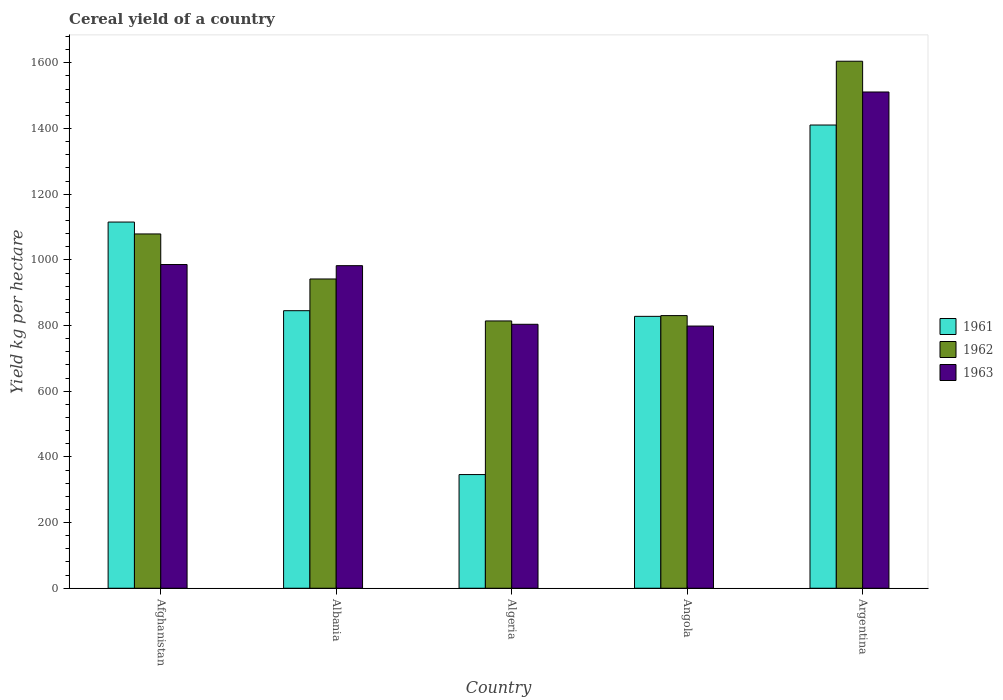Are the number of bars per tick equal to the number of legend labels?
Offer a terse response. Yes. Are the number of bars on each tick of the X-axis equal?
Offer a very short reply. Yes. How many bars are there on the 3rd tick from the right?
Make the answer very short. 3. What is the label of the 3rd group of bars from the left?
Ensure brevity in your answer.  Algeria. In how many cases, is the number of bars for a given country not equal to the number of legend labels?
Offer a terse response. 0. What is the total cereal yield in 1961 in Algeria?
Provide a short and direct response. 346.15. Across all countries, what is the maximum total cereal yield in 1963?
Make the answer very short. 1511.24. Across all countries, what is the minimum total cereal yield in 1962?
Your response must be concise. 814. In which country was the total cereal yield in 1963 maximum?
Your response must be concise. Argentina. In which country was the total cereal yield in 1963 minimum?
Give a very brief answer. Angola. What is the total total cereal yield in 1963 in the graph?
Offer a terse response. 5081.71. What is the difference between the total cereal yield in 1962 in Angola and that in Argentina?
Your response must be concise. -774.65. What is the difference between the total cereal yield in 1963 in Algeria and the total cereal yield in 1962 in Angola?
Keep it short and to the point. -26.44. What is the average total cereal yield in 1961 per country?
Provide a succinct answer. 909.03. What is the difference between the total cereal yield of/in 1963 and total cereal yield of/in 1962 in Argentina?
Your answer should be very brief. -93.68. In how many countries, is the total cereal yield in 1961 greater than 640 kg per hectare?
Offer a terse response. 4. What is the ratio of the total cereal yield in 1961 in Albania to that in Angola?
Provide a short and direct response. 1.02. Is the total cereal yield in 1961 in Afghanistan less than that in Argentina?
Your response must be concise. Yes. Is the difference between the total cereal yield in 1963 in Albania and Algeria greater than the difference between the total cereal yield in 1962 in Albania and Algeria?
Keep it short and to the point. Yes. What is the difference between the highest and the second highest total cereal yield in 1963?
Ensure brevity in your answer.  3.51. What is the difference between the highest and the lowest total cereal yield in 1963?
Your answer should be compact. 712.79. What does the 1st bar from the left in Algeria represents?
Make the answer very short. 1961. Is it the case that in every country, the sum of the total cereal yield in 1963 and total cereal yield in 1962 is greater than the total cereal yield in 1961?
Provide a succinct answer. Yes. Are the values on the major ticks of Y-axis written in scientific E-notation?
Your answer should be compact. No. Does the graph contain grids?
Make the answer very short. No. How many legend labels are there?
Your answer should be compact. 3. How are the legend labels stacked?
Offer a terse response. Vertical. What is the title of the graph?
Offer a very short reply. Cereal yield of a country. What is the label or title of the X-axis?
Offer a very short reply. Country. What is the label or title of the Y-axis?
Your response must be concise. Yield kg per hectare. What is the Yield kg per hectare of 1961 in Afghanistan?
Your answer should be very brief. 1115.13. What is the Yield kg per hectare in 1962 in Afghanistan?
Make the answer very short. 1078.97. What is the Yield kg per hectare in 1963 in Afghanistan?
Your response must be concise. 985.85. What is the Yield kg per hectare in 1961 in Albania?
Your response must be concise. 845.21. What is the Yield kg per hectare of 1962 in Albania?
Give a very brief answer. 941.8. What is the Yield kg per hectare in 1963 in Albania?
Keep it short and to the point. 982.34. What is the Yield kg per hectare of 1961 in Algeria?
Your response must be concise. 346.15. What is the Yield kg per hectare of 1962 in Algeria?
Offer a very short reply. 814. What is the Yield kg per hectare of 1963 in Algeria?
Ensure brevity in your answer.  803.83. What is the Yield kg per hectare of 1961 in Angola?
Your answer should be compact. 828.01. What is the Yield kg per hectare of 1962 in Angola?
Make the answer very short. 830.27. What is the Yield kg per hectare of 1963 in Angola?
Provide a succinct answer. 798.45. What is the Yield kg per hectare of 1961 in Argentina?
Offer a terse response. 1410.65. What is the Yield kg per hectare in 1962 in Argentina?
Provide a succinct answer. 1604.92. What is the Yield kg per hectare of 1963 in Argentina?
Your response must be concise. 1511.24. Across all countries, what is the maximum Yield kg per hectare of 1961?
Ensure brevity in your answer.  1410.65. Across all countries, what is the maximum Yield kg per hectare in 1962?
Offer a very short reply. 1604.92. Across all countries, what is the maximum Yield kg per hectare in 1963?
Your answer should be compact. 1511.24. Across all countries, what is the minimum Yield kg per hectare in 1961?
Provide a succinct answer. 346.15. Across all countries, what is the minimum Yield kg per hectare of 1962?
Ensure brevity in your answer.  814. Across all countries, what is the minimum Yield kg per hectare of 1963?
Provide a short and direct response. 798.45. What is the total Yield kg per hectare in 1961 in the graph?
Your response must be concise. 4545.15. What is the total Yield kg per hectare of 1962 in the graph?
Provide a succinct answer. 5269.97. What is the total Yield kg per hectare in 1963 in the graph?
Provide a succinct answer. 5081.71. What is the difference between the Yield kg per hectare in 1961 in Afghanistan and that in Albania?
Offer a terse response. 269.93. What is the difference between the Yield kg per hectare in 1962 in Afghanistan and that in Albania?
Offer a terse response. 137.17. What is the difference between the Yield kg per hectare in 1963 in Afghanistan and that in Albania?
Ensure brevity in your answer.  3.51. What is the difference between the Yield kg per hectare in 1961 in Afghanistan and that in Algeria?
Your answer should be very brief. 768.98. What is the difference between the Yield kg per hectare in 1962 in Afghanistan and that in Algeria?
Ensure brevity in your answer.  264.97. What is the difference between the Yield kg per hectare of 1963 in Afghanistan and that in Algeria?
Offer a terse response. 182.01. What is the difference between the Yield kg per hectare of 1961 in Afghanistan and that in Angola?
Your response must be concise. 287.13. What is the difference between the Yield kg per hectare in 1962 in Afghanistan and that in Angola?
Provide a short and direct response. 248.69. What is the difference between the Yield kg per hectare in 1963 in Afghanistan and that in Angola?
Make the answer very short. 187.4. What is the difference between the Yield kg per hectare in 1961 in Afghanistan and that in Argentina?
Your response must be concise. -295.52. What is the difference between the Yield kg per hectare of 1962 in Afghanistan and that in Argentina?
Offer a very short reply. -525.96. What is the difference between the Yield kg per hectare in 1963 in Afghanistan and that in Argentina?
Your response must be concise. -525.4. What is the difference between the Yield kg per hectare in 1961 in Albania and that in Algeria?
Provide a short and direct response. 499.05. What is the difference between the Yield kg per hectare in 1962 in Albania and that in Algeria?
Ensure brevity in your answer.  127.8. What is the difference between the Yield kg per hectare of 1963 in Albania and that in Algeria?
Provide a succinct answer. 178.51. What is the difference between the Yield kg per hectare in 1961 in Albania and that in Angola?
Keep it short and to the point. 17.2. What is the difference between the Yield kg per hectare in 1962 in Albania and that in Angola?
Give a very brief answer. 111.52. What is the difference between the Yield kg per hectare of 1963 in Albania and that in Angola?
Give a very brief answer. 183.89. What is the difference between the Yield kg per hectare of 1961 in Albania and that in Argentina?
Make the answer very short. -565.45. What is the difference between the Yield kg per hectare of 1962 in Albania and that in Argentina?
Offer a terse response. -663.13. What is the difference between the Yield kg per hectare of 1963 in Albania and that in Argentina?
Offer a terse response. -528.9. What is the difference between the Yield kg per hectare of 1961 in Algeria and that in Angola?
Keep it short and to the point. -481.85. What is the difference between the Yield kg per hectare of 1962 in Algeria and that in Angola?
Ensure brevity in your answer.  -16.27. What is the difference between the Yield kg per hectare in 1963 in Algeria and that in Angola?
Provide a short and direct response. 5.38. What is the difference between the Yield kg per hectare of 1961 in Algeria and that in Argentina?
Ensure brevity in your answer.  -1064.5. What is the difference between the Yield kg per hectare of 1962 in Algeria and that in Argentina?
Your response must be concise. -790.92. What is the difference between the Yield kg per hectare of 1963 in Algeria and that in Argentina?
Give a very brief answer. -707.41. What is the difference between the Yield kg per hectare of 1961 in Angola and that in Argentina?
Keep it short and to the point. -582.65. What is the difference between the Yield kg per hectare in 1962 in Angola and that in Argentina?
Your answer should be very brief. -774.65. What is the difference between the Yield kg per hectare in 1963 in Angola and that in Argentina?
Your answer should be compact. -712.79. What is the difference between the Yield kg per hectare of 1961 in Afghanistan and the Yield kg per hectare of 1962 in Albania?
Your answer should be compact. 173.34. What is the difference between the Yield kg per hectare in 1961 in Afghanistan and the Yield kg per hectare in 1963 in Albania?
Make the answer very short. 132.8. What is the difference between the Yield kg per hectare of 1962 in Afghanistan and the Yield kg per hectare of 1963 in Albania?
Offer a very short reply. 96.63. What is the difference between the Yield kg per hectare of 1961 in Afghanistan and the Yield kg per hectare of 1962 in Algeria?
Your response must be concise. 301.13. What is the difference between the Yield kg per hectare in 1961 in Afghanistan and the Yield kg per hectare in 1963 in Algeria?
Provide a short and direct response. 311.3. What is the difference between the Yield kg per hectare in 1962 in Afghanistan and the Yield kg per hectare in 1963 in Algeria?
Keep it short and to the point. 275.13. What is the difference between the Yield kg per hectare of 1961 in Afghanistan and the Yield kg per hectare of 1962 in Angola?
Your answer should be very brief. 284.86. What is the difference between the Yield kg per hectare of 1961 in Afghanistan and the Yield kg per hectare of 1963 in Angola?
Your answer should be compact. 316.69. What is the difference between the Yield kg per hectare in 1962 in Afghanistan and the Yield kg per hectare in 1963 in Angola?
Ensure brevity in your answer.  280.52. What is the difference between the Yield kg per hectare of 1961 in Afghanistan and the Yield kg per hectare of 1962 in Argentina?
Make the answer very short. -489.79. What is the difference between the Yield kg per hectare in 1961 in Afghanistan and the Yield kg per hectare in 1963 in Argentina?
Keep it short and to the point. -396.11. What is the difference between the Yield kg per hectare of 1962 in Afghanistan and the Yield kg per hectare of 1963 in Argentina?
Offer a terse response. -432.28. What is the difference between the Yield kg per hectare of 1961 in Albania and the Yield kg per hectare of 1962 in Algeria?
Provide a short and direct response. 31.2. What is the difference between the Yield kg per hectare in 1961 in Albania and the Yield kg per hectare in 1963 in Algeria?
Give a very brief answer. 41.37. What is the difference between the Yield kg per hectare of 1962 in Albania and the Yield kg per hectare of 1963 in Algeria?
Keep it short and to the point. 137.97. What is the difference between the Yield kg per hectare of 1961 in Albania and the Yield kg per hectare of 1962 in Angola?
Offer a very short reply. 14.93. What is the difference between the Yield kg per hectare in 1961 in Albania and the Yield kg per hectare in 1963 in Angola?
Offer a very short reply. 46.76. What is the difference between the Yield kg per hectare of 1962 in Albania and the Yield kg per hectare of 1963 in Angola?
Your response must be concise. 143.35. What is the difference between the Yield kg per hectare in 1961 in Albania and the Yield kg per hectare in 1962 in Argentina?
Provide a short and direct response. -759.72. What is the difference between the Yield kg per hectare in 1961 in Albania and the Yield kg per hectare in 1963 in Argentina?
Your answer should be compact. -666.04. What is the difference between the Yield kg per hectare in 1962 in Albania and the Yield kg per hectare in 1963 in Argentina?
Your response must be concise. -569.44. What is the difference between the Yield kg per hectare of 1961 in Algeria and the Yield kg per hectare of 1962 in Angola?
Offer a terse response. -484.12. What is the difference between the Yield kg per hectare of 1961 in Algeria and the Yield kg per hectare of 1963 in Angola?
Give a very brief answer. -452.3. What is the difference between the Yield kg per hectare in 1962 in Algeria and the Yield kg per hectare in 1963 in Angola?
Give a very brief answer. 15.55. What is the difference between the Yield kg per hectare in 1961 in Algeria and the Yield kg per hectare in 1962 in Argentina?
Make the answer very short. -1258.77. What is the difference between the Yield kg per hectare in 1961 in Algeria and the Yield kg per hectare in 1963 in Argentina?
Make the answer very short. -1165.09. What is the difference between the Yield kg per hectare of 1962 in Algeria and the Yield kg per hectare of 1963 in Argentina?
Provide a short and direct response. -697.24. What is the difference between the Yield kg per hectare in 1961 in Angola and the Yield kg per hectare in 1962 in Argentina?
Your answer should be very brief. -776.92. What is the difference between the Yield kg per hectare in 1961 in Angola and the Yield kg per hectare in 1963 in Argentina?
Keep it short and to the point. -683.24. What is the difference between the Yield kg per hectare in 1962 in Angola and the Yield kg per hectare in 1963 in Argentina?
Provide a short and direct response. -680.97. What is the average Yield kg per hectare of 1961 per country?
Your response must be concise. 909.03. What is the average Yield kg per hectare of 1962 per country?
Offer a very short reply. 1053.99. What is the average Yield kg per hectare of 1963 per country?
Ensure brevity in your answer.  1016.34. What is the difference between the Yield kg per hectare in 1961 and Yield kg per hectare in 1962 in Afghanistan?
Your answer should be compact. 36.17. What is the difference between the Yield kg per hectare in 1961 and Yield kg per hectare in 1963 in Afghanistan?
Your answer should be very brief. 129.29. What is the difference between the Yield kg per hectare of 1962 and Yield kg per hectare of 1963 in Afghanistan?
Give a very brief answer. 93.12. What is the difference between the Yield kg per hectare of 1961 and Yield kg per hectare of 1962 in Albania?
Provide a succinct answer. -96.59. What is the difference between the Yield kg per hectare of 1961 and Yield kg per hectare of 1963 in Albania?
Give a very brief answer. -137.13. What is the difference between the Yield kg per hectare of 1962 and Yield kg per hectare of 1963 in Albania?
Your answer should be very brief. -40.54. What is the difference between the Yield kg per hectare of 1961 and Yield kg per hectare of 1962 in Algeria?
Make the answer very short. -467.85. What is the difference between the Yield kg per hectare of 1961 and Yield kg per hectare of 1963 in Algeria?
Your answer should be very brief. -457.68. What is the difference between the Yield kg per hectare in 1962 and Yield kg per hectare in 1963 in Algeria?
Offer a terse response. 10.17. What is the difference between the Yield kg per hectare in 1961 and Yield kg per hectare in 1962 in Angola?
Offer a very short reply. -2.27. What is the difference between the Yield kg per hectare of 1961 and Yield kg per hectare of 1963 in Angola?
Offer a terse response. 29.56. What is the difference between the Yield kg per hectare of 1962 and Yield kg per hectare of 1963 in Angola?
Give a very brief answer. 31.82. What is the difference between the Yield kg per hectare of 1961 and Yield kg per hectare of 1962 in Argentina?
Provide a short and direct response. -194.27. What is the difference between the Yield kg per hectare of 1961 and Yield kg per hectare of 1963 in Argentina?
Offer a very short reply. -100.59. What is the difference between the Yield kg per hectare of 1962 and Yield kg per hectare of 1963 in Argentina?
Make the answer very short. 93.68. What is the ratio of the Yield kg per hectare in 1961 in Afghanistan to that in Albania?
Ensure brevity in your answer.  1.32. What is the ratio of the Yield kg per hectare of 1962 in Afghanistan to that in Albania?
Ensure brevity in your answer.  1.15. What is the ratio of the Yield kg per hectare of 1961 in Afghanistan to that in Algeria?
Provide a succinct answer. 3.22. What is the ratio of the Yield kg per hectare of 1962 in Afghanistan to that in Algeria?
Your answer should be very brief. 1.33. What is the ratio of the Yield kg per hectare of 1963 in Afghanistan to that in Algeria?
Offer a terse response. 1.23. What is the ratio of the Yield kg per hectare in 1961 in Afghanistan to that in Angola?
Your response must be concise. 1.35. What is the ratio of the Yield kg per hectare of 1962 in Afghanistan to that in Angola?
Offer a terse response. 1.3. What is the ratio of the Yield kg per hectare in 1963 in Afghanistan to that in Angola?
Provide a short and direct response. 1.23. What is the ratio of the Yield kg per hectare in 1961 in Afghanistan to that in Argentina?
Offer a very short reply. 0.79. What is the ratio of the Yield kg per hectare in 1962 in Afghanistan to that in Argentina?
Ensure brevity in your answer.  0.67. What is the ratio of the Yield kg per hectare of 1963 in Afghanistan to that in Argentina?
Make the answer very short. 0.65. What is the ratio of the Yield kg per hectare in 1961 in Albania to that in Algeria?
Keep it short and to the point. 2.44. What is the ratio of the Yield kg per hectare in 1962 in Albania to that in Algeria?
Offer a terse response. 1.16. What is the ratio of the Yield kg per hectare of 1963 in Albania to that in Algeria?
Ensure brevity in your answer.  1.22. What is the ratio of the Yield kg per hectare of 1961 in Albania to that in Angola?
Give a very brief answer. 1.02. What is the ratio of the Yield kg per hectare in 1962 in Albania to that in Angola?
Keep it short and to the point. 1.13. What is the ratio of the Yield kg per hectare of 1963 in Albania to that in Angola?
Keep it short and to the point. 1.23. What is the ratio of the Yield kg per hectare of 1961 in Albania to that in Argentina?
Provide a short and direct response. 0.6. What is the ratio of the Yield kg per hectare in 1962 in Albania to that in Argentina?
Make the answer very short. 0.59. What is the ratio of the Yield kg per hectare of 1963 in Albania to that in Argentina?
Offer a terse response. 0.65. What is the ratio of the Yield kg per hectare in 1961 in Algeria to that in Angola?
Offer a terse response. 0.42. What is the ratio of the Yield kg per hectare in 1962 in Algeria to that in Angola?
Keep it short and to the point. 0.98. What is the ratio of the Yield kg per hectare in 1963 in Algeria to that in Angola?
Give a very brief answer. 1.01. What is the ratio of the Yield kg per hectare in 1961 in Algeria to that in Argentina?
Ensure brevity in your answer.  0.25. What is the ratio of the Yield kg per hectare in 1962 in Algeria to that in Argentina?
Your answer should be very brief. 0.51. What is the ratio of the Yield kg per hectare of 1963 in Algeria to that in Argentina?
Your answer should be compact. 0.53. What is the ratio of the Yield kg per hectare of 1961 in Angola to that in Argentina?
Give a very brief answer. 0.59. What is the ratio of the Yield kg per hectare in 1962 in Angola to that in Argentina?
Offer a very short reply. 0.52. What is the ratio of the Yield kg per hectare in 1963 in Angola to that in Argentina?
Provide a short and direct response. 0.53. What is the difference between the highest and the second highest Yield kg per hectare of 1961?
Offer a very short reply. 295.52. What is the difference between the highest and the second highest Yield kg per hectare in 1962?
Make the answer very short. 525.96. What is the difference between the highest and the second highest Yield kg per hectare of 1963?
Give a very brief answer. 525.4. What is the difference between the highest and the lowest Yield kg per hectare in 1961?
Your response must be concise. 1064.5. What is the difference between the highest and the lowest Yield kg per hectare of 1962?
Keep it short and to the point. 790.92. What is the difference between the highest and the lowest Yield kg per hectare in 1963?
Your response must be concise. 712.79. 